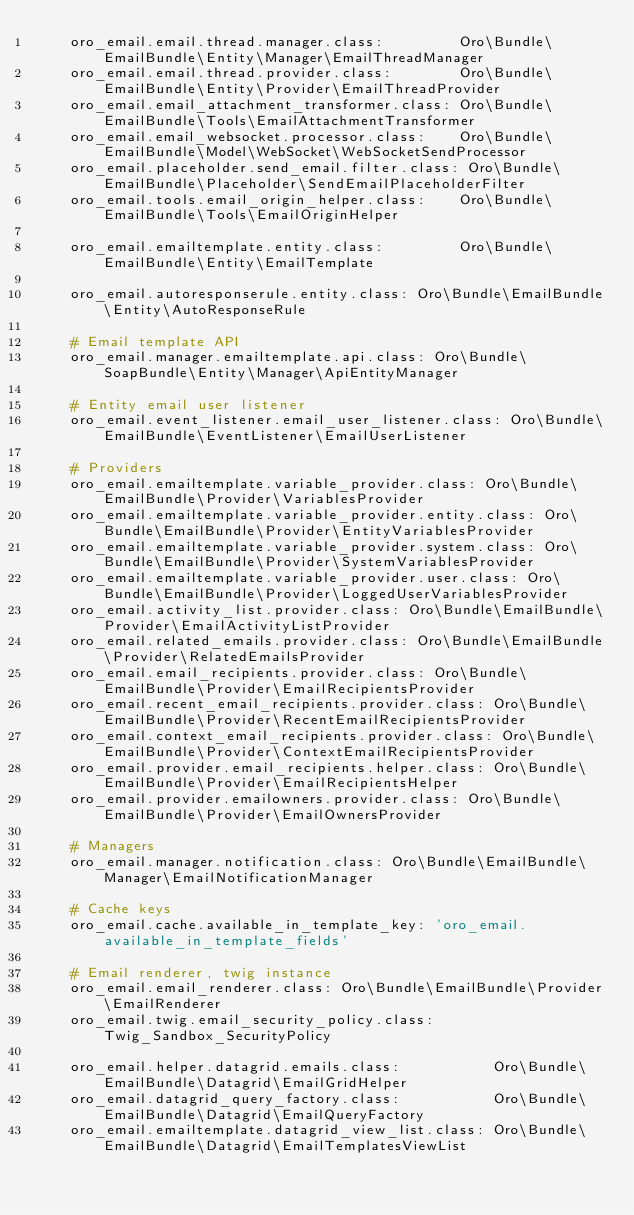<code> <loc_0><loc_0><loc_500><loc_500><_YAML_>    oro_email.email.thread.manager.class:         Oro\Bundle\EmailBundle\Entity\Manager\EmailThreadManager
    oro_email.email.thread.provider.class:        Oro\Bundle\EmailBundle\Entity\Provider\EmailThreadProvider
    oro_email.email_attachment_transformer.class: Oro\Bundle\EmailBundle\Tools\EmailAttachmentTransformer
    oro_email.email_websocket.processor.class:    Oro\Bundle\EmailBundle\Model\WebSocket\WebSocketSendProcessor
    oro_email.placeholder.send_email.filter.class: Oro\Bundle\EmailBundle\Placeholder\SendEmailPlaceholderFilter
    oro_email.tools.email_origin_helper.class:    Oro\Bundle\EmailBundle\Tools\EmailOriginHelper

    oro_email.emailtemplate.entity.class:         Oro\Bundle\EmailBundle\Entity\EmailTemplate

    oro_email.autoresponserule.entity.class: Oro\Bundle\EmailBundle\Entity\AutoResponseRule

    # Email template API
    oro_email.manager.emailtemplate.api.class: Oro\Bundle\SoapBundle\Entity\Manager\ApiEntityManager

    # Entity email user listener
    oro_email.event_listener.email_user_listener.class: Oro\Bundle\EmailBundle\EventListener\EmailUserListener

    # Providers
    oro_email.emailtemplate.variable_provider.class: Oro\Bundle\EmailBundle\Provider\VariablesProvider
    oro_email.emailtemplate.variable_provider.entity.class: Oro\Bundle\EmailBundle\Provider\EntityVariablesProvider
    oro_email.emailtemplate.variable_provider.system.class: Oro\Bundle\EmailBundle\Provider\SystemVariablesProvider
    oro_email.emailtemplate.variable_provider.user.class: Oro\Bundle\EmailBundle\Provider\LoggedUserVariablesProvider
    oro_email.activity_list.provider.class: Oro\Bundle\EmailBundle\Provider\EmailActivityListProvider
    oro_email.related_emails.provider.class: Oro\Bundle\EmailBundle\Provider\RelatedEmailsProvider
    oro_email.email_recipients.provider.class: Oro\Bundle\EmailBundle\Provider\EmailRecipientsProvider
    oro_email.recent_email_recipients.provider.class: Oro\Bundle\EmailBundle\Provider\RecentEmailRecipientsProvider
    oro_email.context_email_recipients.provider.class: Oro\Bundle\EmailBundle\Provider\ContextEmailRecipientsProvider
    oro_email.provider.email_recipients.helper.class: Oro\Bundle\EmailBundle\Provider\EmailRecipientsHelper
    oro_email.provider.emailowners.provider.class: Oro\Bundle\EmailBundle\Provider\EmailOwnersProvider

    # Managers
    oro_email.manager.notification.class: Oro\Bundle\EmailBundle\Manager\EmailNotificationManager

    # Cache keys
    oro_email.cache.available_in_template_key: 'oro_email.available_in_template_fields'

    # Email renderer, twig instance
    oro_email.email_renderer.class: Oro\Bundle\EmailBundle\Provider\EmailRenderer
    oro_email.twig.email_security_policy.class: Twig_Sandbox_SecurityPolicy

    oro_email.helper.datagrid.emails.class:           Oro\Bundle\EmailBundle\Datagrid\EmailGridHelper
    oro_email.datagrid_query_factory.class:           Oro\Bundle\EmailBundle\Datagrid\EmailQueryFactory
    oro_email.emailtemplate.datagrid_view_list.class: Oro\Bundle\EmailBundle\Datagrid\EmailTemplatesViewList</code> 